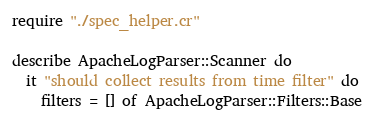<code> <loc_0><loc_0><loc_500><loc_500><_Crystal_>require "./spec_helper.cr"

describe ApacheLogParser::Scanner do
  it "should collect results from time filter" do
    filters = [] of ApacheLogParser::Filters::Base</code> 